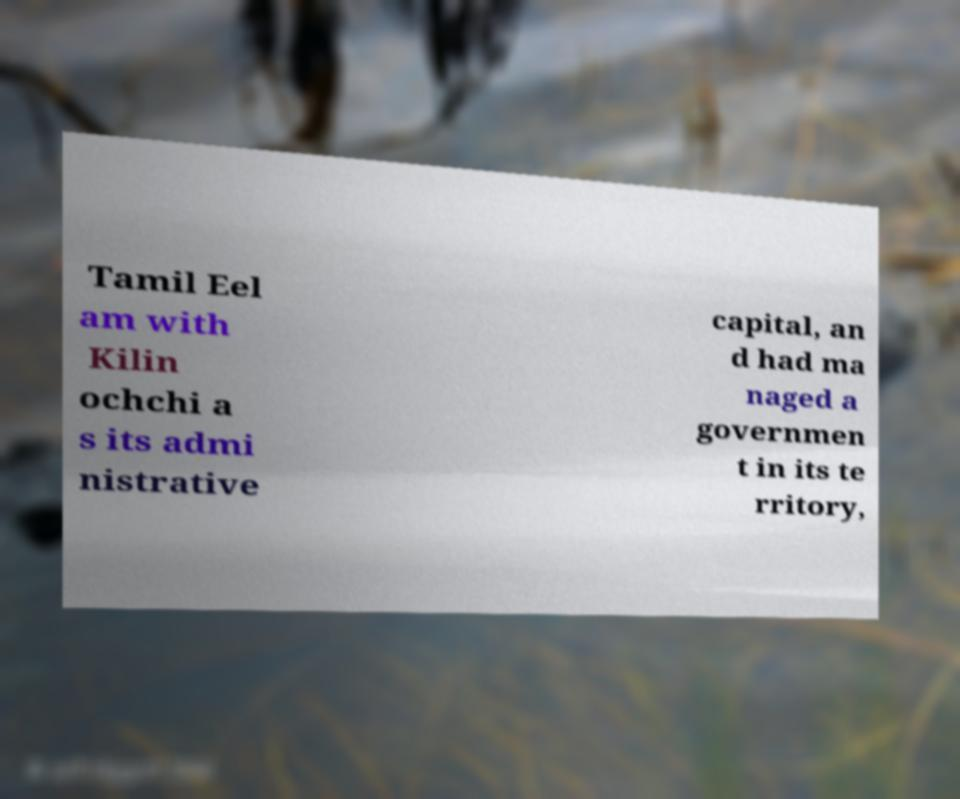Could you extract and type out the text from this image? Tamil Eel am with Kilin ochchi a s its admi nistrative capital, an d had ma naged a governmen t in its te rritory, 